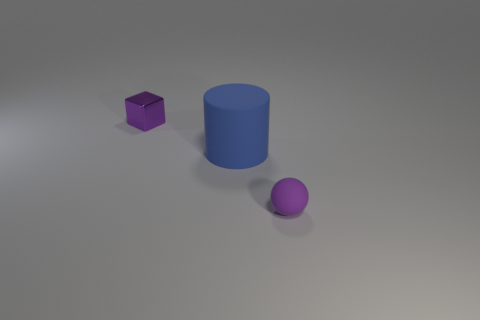How many purple things are both to the left of the purple sphere and in front of the blue rubber object?
Offer a terse response. 0. How many other objects are there of the same size as the purple metal thing?
Your answer should be compact. 1. There is a rubber object that is on the left side of the tiny rubber thing; is its shape the same as the purple thing that is right of the small purple cube?
Ensure brevity in your answer.  No. How many things are tiny rubber things or tiny purple things that are in front of the blue matte cylinder?
Your answer should be very brief. 1. There is a object that is on the right side of the small metallic object and behind the tiny matte ball; what material is it?
Provide a succinct answer. Rubber. Is there any other thing that has the same shape as the large blue thing?
Provide a succinct answer. No. What color is the big cylinder that is made of the same material as the purple ball?
Your response must be concise. Blue. How many things are either small rubber things or blue objects?
Make the answer very short. 2. There is a purple matte thing; is its size the same as the purple object that is to the left of the big blue rubber cylinder?
Offer a very short reply. Yes. There is a matte thing that is behind the small purple thing that is in front of the purple thing that is on the left side of the big blue cylinder; what is its color?
Provide a short and direct response. Blue. 